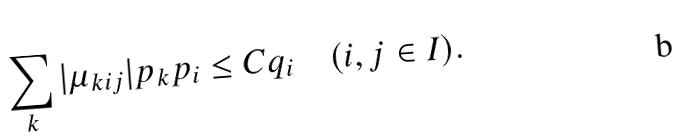Convert formula to latex. <formula><loc_0><loc_0><loc_500><loc_500>\sum _ { k } | \mu _ { k i j } | p _ { k } p _ { i } \leq C q _ { i } \quad ( i , j \in I ) .</formula> 